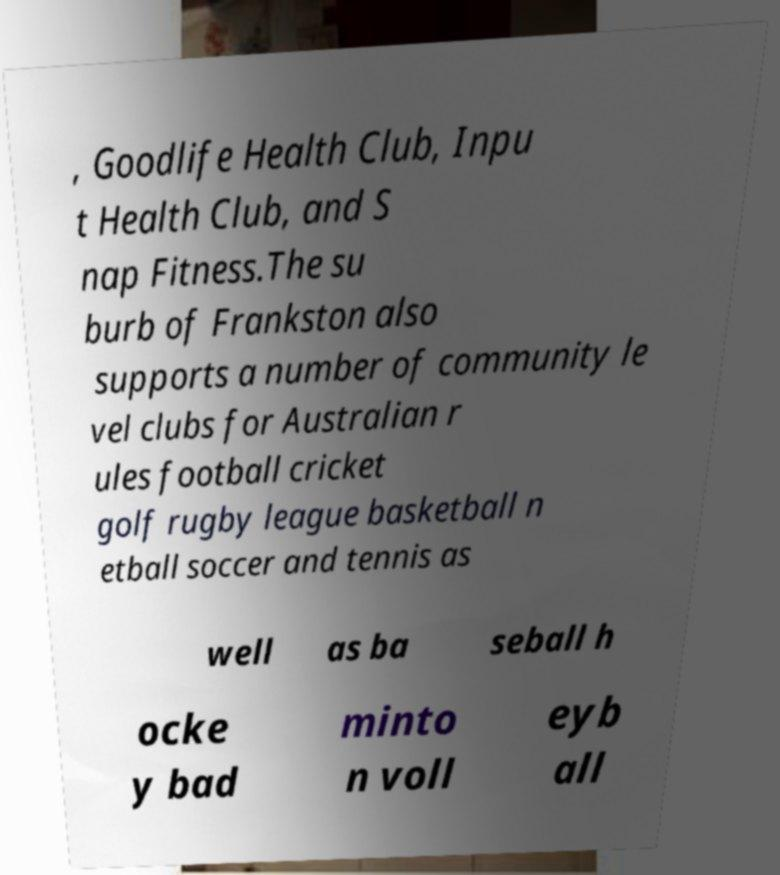For documentation purposes, I need the text within this image transcribed. Could you provide that? , Goodlife Health Club, Inpu t Health Club, and S nap Fitness.The su burb of Frankston also supports a number of community le vel clubs for Australian r ules football cricket golf rugby league basketball n etball soccer and tennis as well as ba seball h ocke y bad minto n voll eyb all 